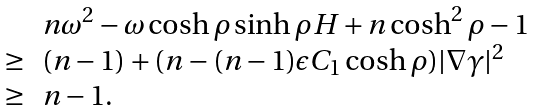<formula> <loc_0><loc_0><loc_500><loc_500>\begin{array} [ ] { r l l } & n \omega ^ { 2 } - \omega \cosh \rho \sinh \rho H + n \cosh ^ { 2 } \rho - 1 \\ \geq & ( n - 1 ) + ( n - ( n - 1 ) \epsilon C _ { 1 } \cosh \rho ) | \nabla \gamma | ^ { 2 } \\ \geq & n - 1 . \end{array}</formula> 